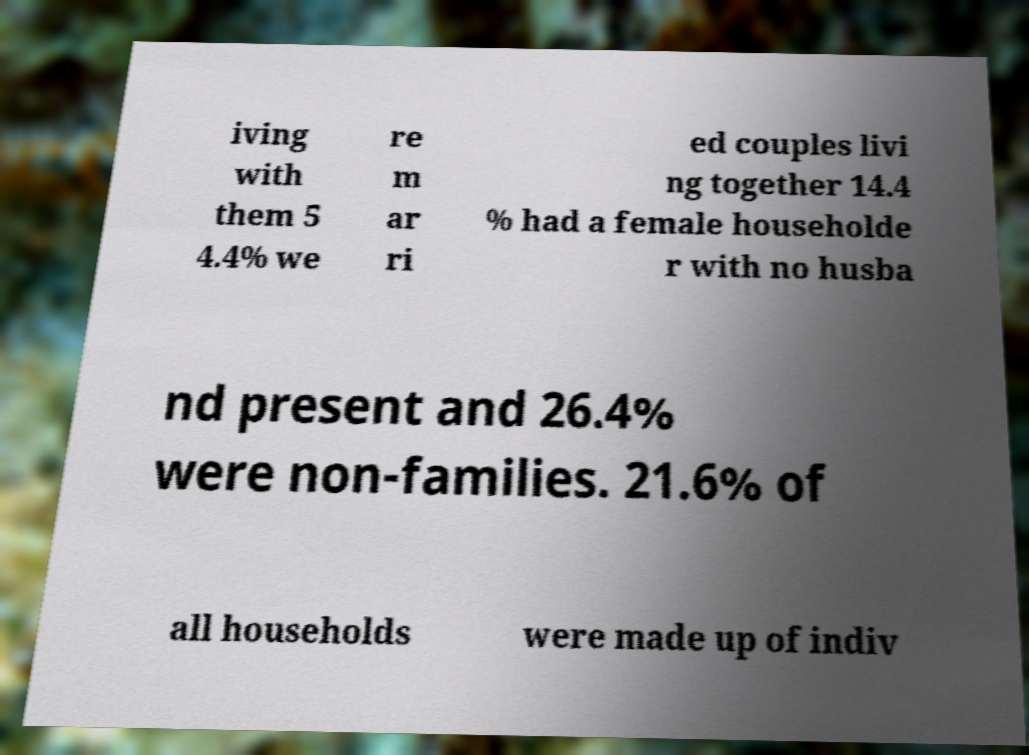Can you accurately transcribe the text from the provided image for me? iving with them 5 4.4% we re m ar ri ed couples livi ng together 14.4 % had a female householde r with no husba nd present and 26.4% were non-families. 21.6% of all households were made up of indiv 